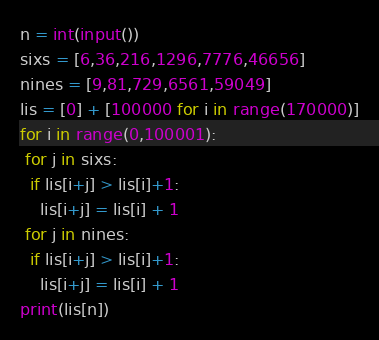Convert code to text. <code><loc_0><loc_0><loc_500><loc_500><_Python_>n = int(input())
sixs = [6,36,216,1296,7776,46656]
nines = [9,81,729,6561,59049]
lis = [0] + [100000 for i in range(170000)]
for i in range(0,100001):
 for j in sixs:
  if lis[i+j] > lis[i]+1:
    lis[i+j] = lis[i] + 1
 for j in nines:
  if lis[i+j] > lis[i]+1:
    lis[i+j] = lis[i] + 1
print(lis[n])</code> 